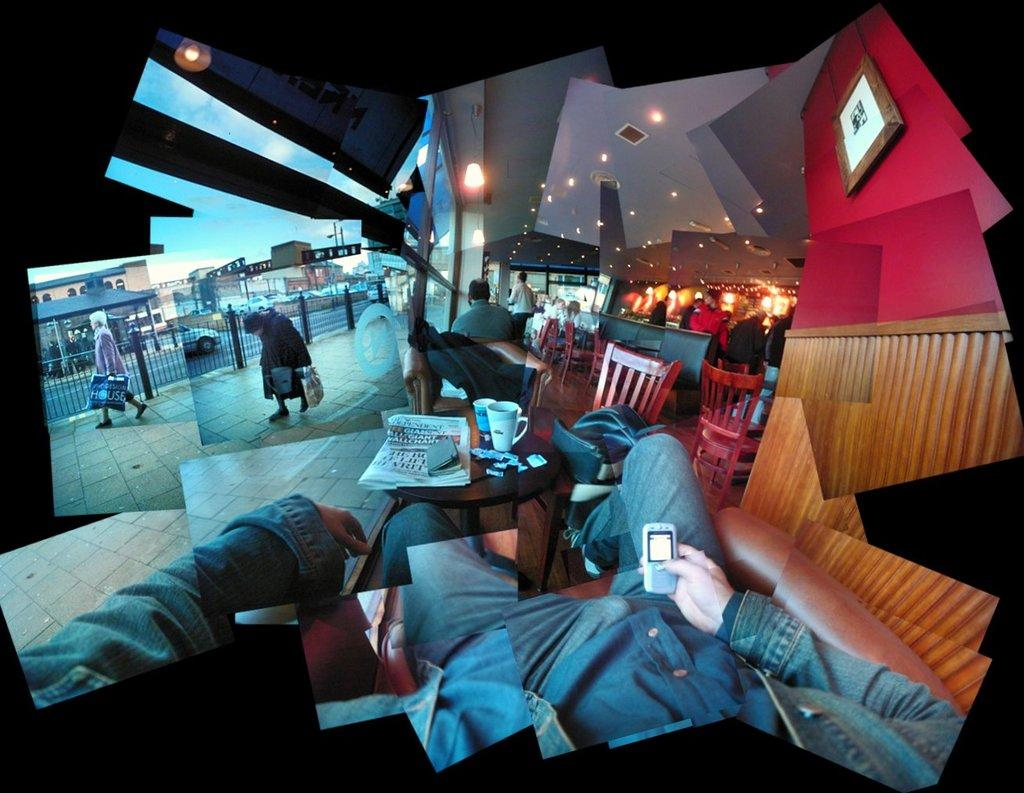What are the people in the image doing? The people in the image are walking on the pavement. Can you describe the setting of the image? There is a person sitting in a restaurant in the image. What type of underwear is the person sitting in the restaurant wearing? There is no information about the person's underwear in the image, so it cannot be determined. 